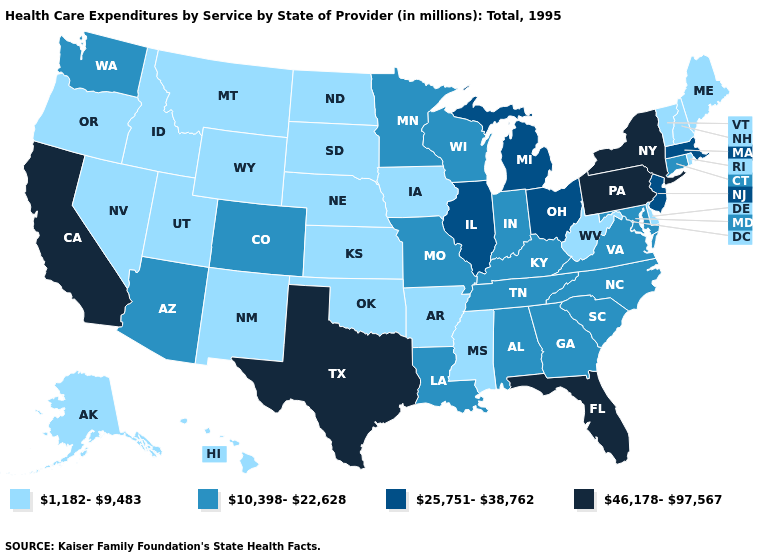What is the value of Alabama?
Answer briefly. 10,398-22,628. What is the lowest value in states that border Wyoming?
Short answer required. 1,182-9,483. Is the legend a continuous bar?
Be succinct. No. What is the highest value in the USA?
Give a very brief answer. 46,178-97,567. Name the states that have a value in the range 46,178-97,567?
Give a very brief answer. California, Florida, New York, Pennsylvania, Texas. How many symbols are there in the legend?
Quick response, please. 4. Which states have the highest value in the USA?
Answer briefly. California, Florida, New York, Pennsylvania, Texas. What is the value of West Virginia?
Keep it brief. 1,182-9,483. What is the lowest value in the Northeast?
Give a very brief answer. 1,182-9,483. Which states hav the highest value in the West?
Write a very short answer. California. Among the states that border Montana , which have the highest value?
Give a very brief answer. Idaho, North Dakota, South Dakota, Wyoming. What is the highest value in the USA?
Short answer required. 46,178-97,567. Does New York have the highest value in the USA?
Short answer required. Yes. Does Delaware have the highest value in the South?
Give a very brief answer. No. What is the value of Texas?
Write a very short answer. 46,178-97,567. 